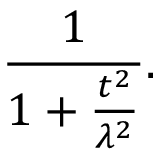Convert formula to latex. <formula><loc_0><loc_0><loc_500><loc_500>{ \frac { 1 } { 1 + { \frac { t ^ { 2 } } { \lambda ^ { 2 } } } } } .</formula> 